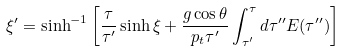<formula> <loc_0><loc_0><loc_500><loc_500>\xi ^ { \prime } = \sinh ^ { - 1 } \left [ \frac { \tau } { \tau ^ { \prime } } \sinh \xi + \frac { g \cos \theta } { p _ { t } \tau ^ { \prime } } \int _ { \tau ^ { \prime } } ^ { \tau } d \tau ^ { \prime \prime } E ( \tau ^ { \prime \prime } ) \right ]</formula> 